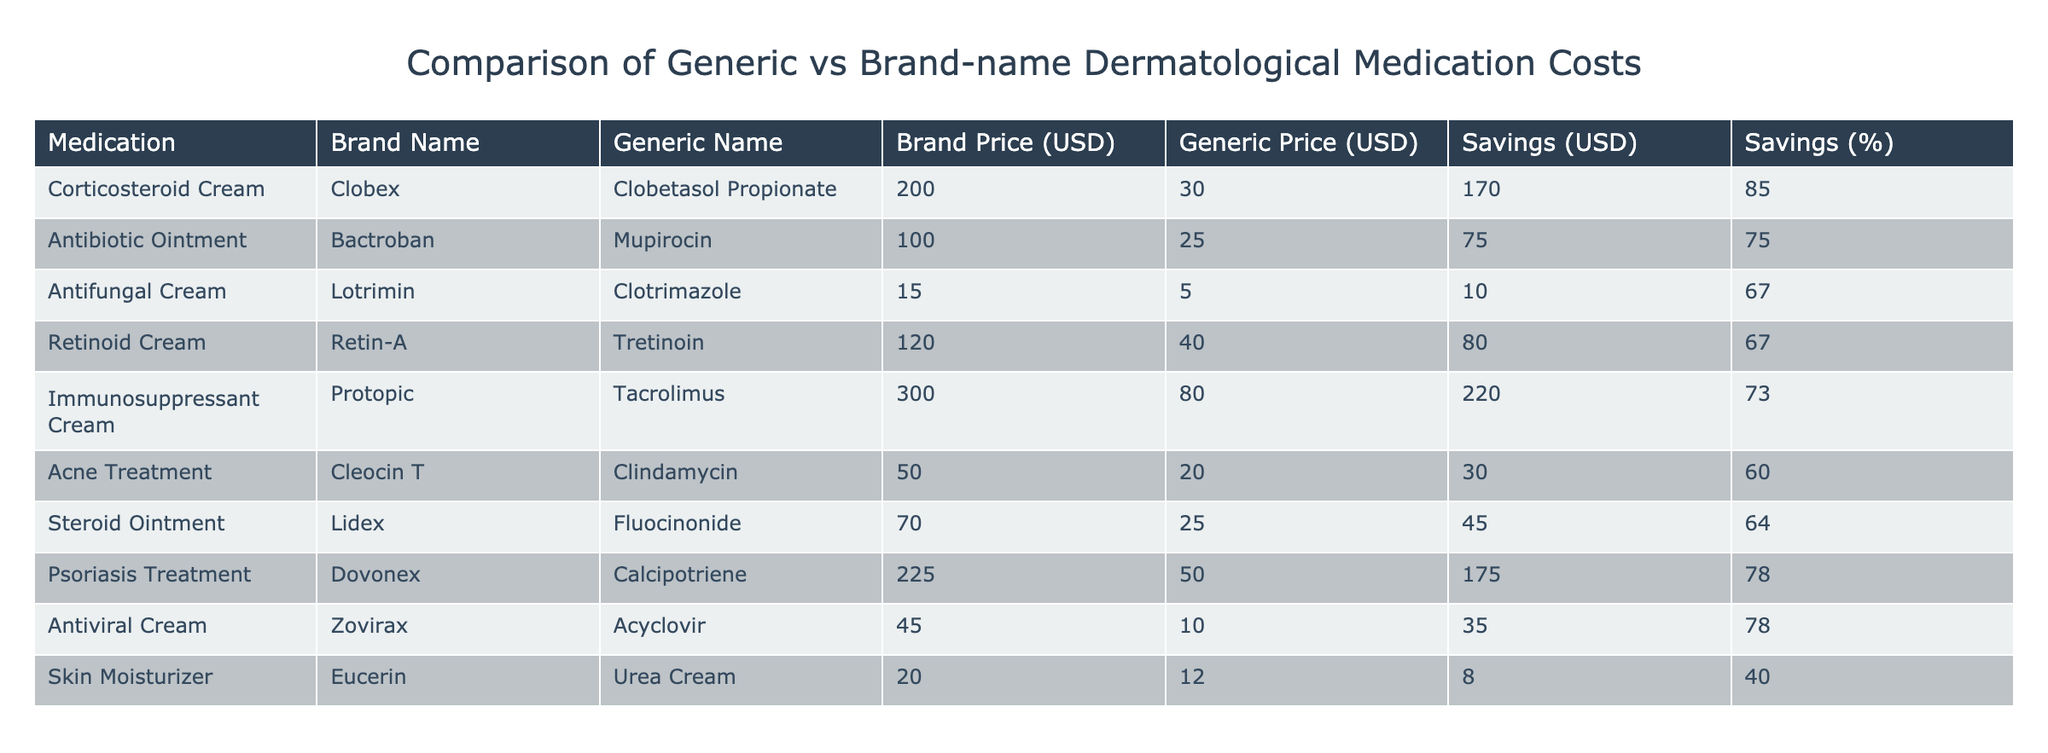What is the price difference between the brand-name Corticosteroid Cream and its generic counterpart? The brand price for Corticosteroid Cream (Clobex) is 200.00 USD, and the generic price (Clobetasol Propionate) is 30.00 USD. The price difference is calculated as 200.00 - 30.00, which equals 170.00 USD.
Answer: 170.00 USD Which medication shows the greatest percentage savings when switching from the brand-name to the generic version? Looking at the "Savings (%)" column, the highest percentage is 85% for the Corticosteroid Cream (Clobex), indicating that this medication offers the most substantial savings when switching to its generic form.
Answer: Corticosteroid Cream (Clobex) at 85% How much would you save by choosing the generic Antifungal Cream over the brand-name version? The brand price for Antifungal Cream (Lotrimin) is 15.00 USD, while the generic (Clotrimazole) costs 5.00 USD. The savings are assessed by finding the difference, resulting in 15.00 - 5.00 = 10.00 USD savings.
Answer: 10.00 USD Is the generic version of the Immunosuppressant Cream cheaper than the brand-name? The brand price for Immunosuppressant Cream (Protopic) is 300.00 USD, and the generic (Tacrolimus) is 80.00 USD. Since 80.00 is less than 300.00, the answer is yes; the generic is cheaper.
Answer: Yes What is the total savings if a patient chooses all the generic medications listed in the table instead of the brand-name versions? To find the total savings, sum the individual savings amounts: 170.00 + 75.00 + 10.00 + 80.00 + 220.00 + 30.00 + 45.00 + 175.00 + 35.00 + 8.00 =  818.00 USD.
Answer: 818.00 USD 